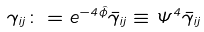Convert formula to latex. <formula><loc_0><loc_0><loc_500><loc_500>\gamma _ { i j } \colon = e ^ { - 4 \hat { \phi } } \bar { \gamma } _ { i j } \equiv \Psi ^ { 4 } \bar { \gamma } _ { i j }</formula> 